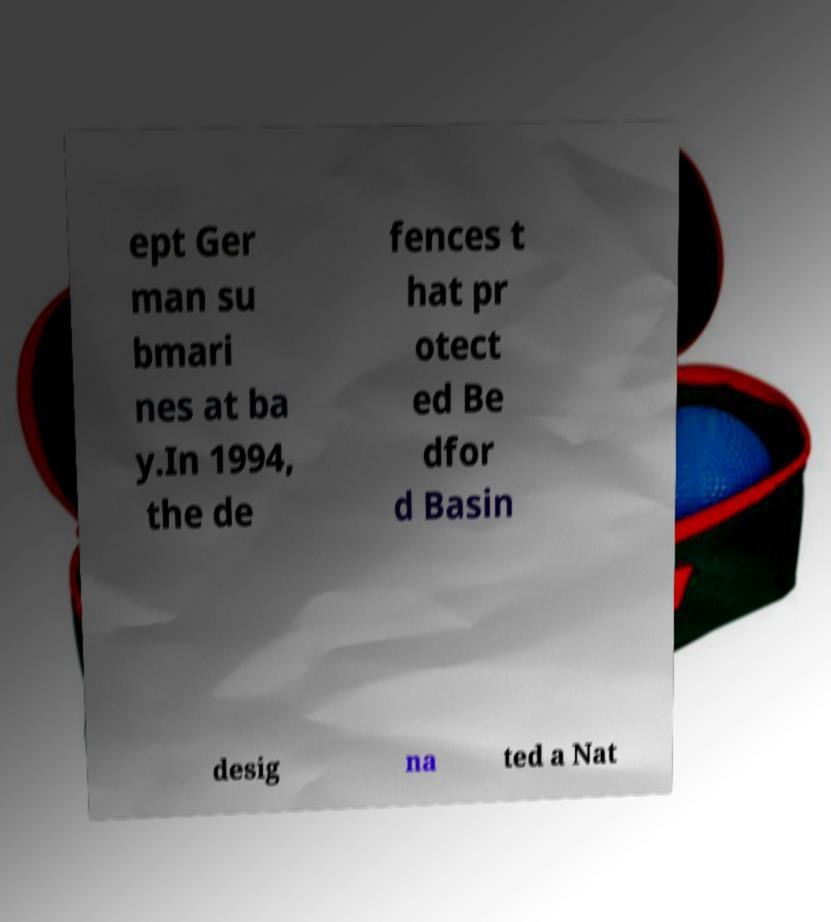Can you accurately transcribe the text from the provided image for me? ept Ger man su bmari nes at ba y.In 1994, the de fences t hat pr otect ed Be dfor d Basin desig na ted a Nat 